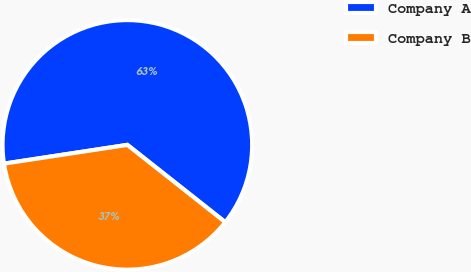Convert chart to OTSL. <chart><loc_0><loc_0><loc_500><loc_500><pie_chart><fcel>Company A<fcel>Company B<nl><fcel>63.04%<fcel>36.96%<nl></chart> 